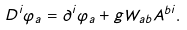Convert formula to latex. <formula><loc_0><loc_0><loc_500><loc_500>D ^ { i } \varphi _ { a } = \partial ^ { i } \varphi _ { a } + g W _ { a b } A ^ { b i } .</formula> 